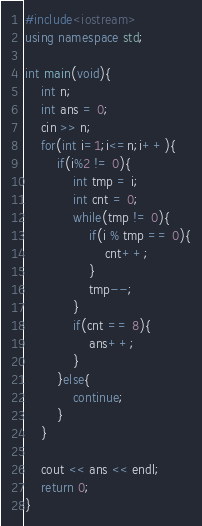Convert code to text. <code><loc_0><loc_0><loc_500><loc_500><_C++_>#include<iostream>
using namespace std;

int main(void){
	int n;
	int ans = 0;
	cin >> n;
	for(int i=1;i<=n;i++){
		if(i%2 != 0){
			int tmp = i;
			int cnt = 0;
			while(tmp != 0){
				if(i % tmp == 0){
					cnt++;
				}
				tmp--;
			}
			if(cnt == 8){
				ans++;
			}
		}else{
			continue;
		}
	}
	
	cout << ans << endl;
	return 0;
}</code> 